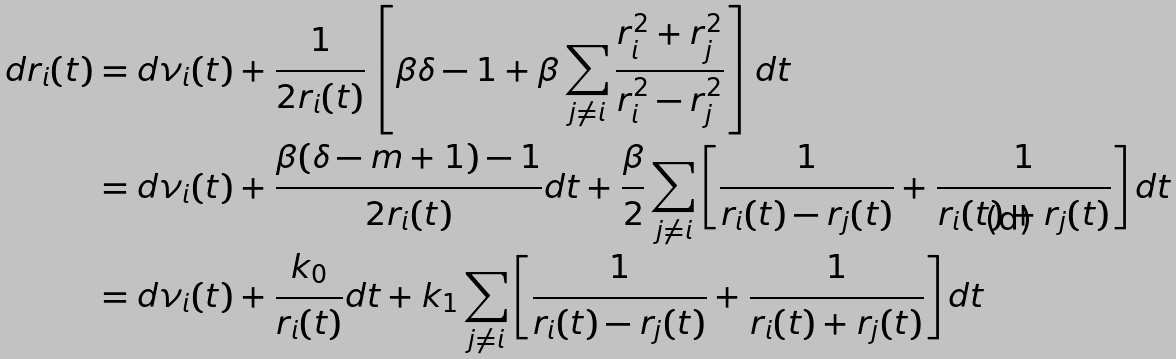Convert formula to latex. <formula><loc_0><loc_0><loc_500><loc_500>d r _ { i } ( t ) & = d \nu _ { i } ( t ) + \frac { 1 } { 2 r _ { i } ( t ) } \left [ \beta \delta - 1 + \beta \sum _ { j \neq i } \frac { r _ { i } ^ { 2 } + r _ { j } ^ { 2 } } { r _ { i } ^ { 2 } - r _ { j } ^ { 2 } } \right ] d t \\ & = d \nu _ { i } ( t ) + \frac { \beta ( \delta - m + 1 ) - 1 } { 2 r _ { i } ( t ) } d t + \frac { \beta } { 2 } \sum _ { j \neq i } \left [ \frac { 1 } { r _ { i } ( t ) - r _ { j } ( t ) } + \frac { 1 } { r _ { i } ( t ) + r _ { j } ( t ) } \right ] d t \\ & = d \nu _ { i } ( t ) + \frac { k _ { 0 } } { r _ { i } ( t ) } d t + k _ { 1 } \sum _ { j \neq i } \left [ \frac { 1 } { r _ { i } ( t ) - r _ { j } ( t ) } + \frac { 1 } { r _ { i } ( t ) + r _ { j } ( t ) } \right ] d t</formula> 